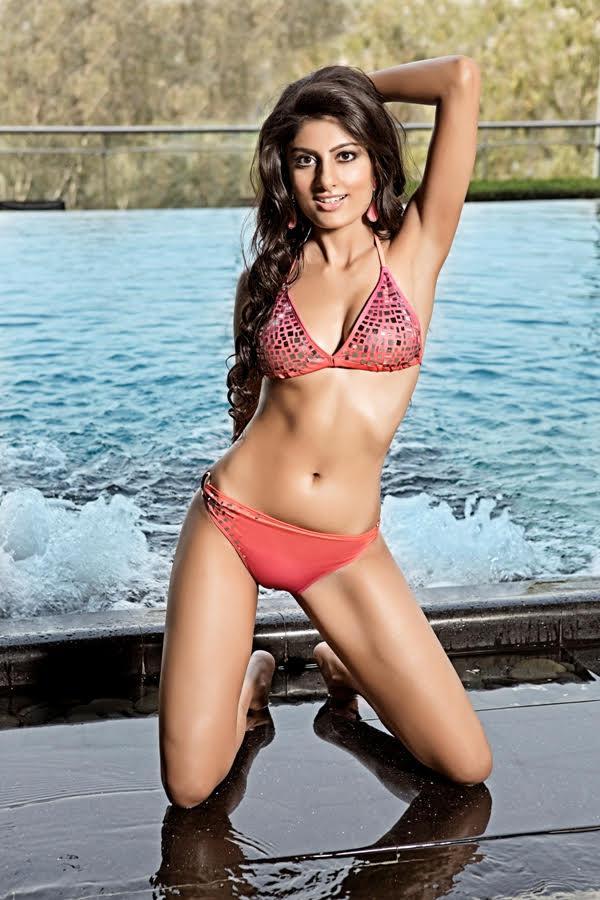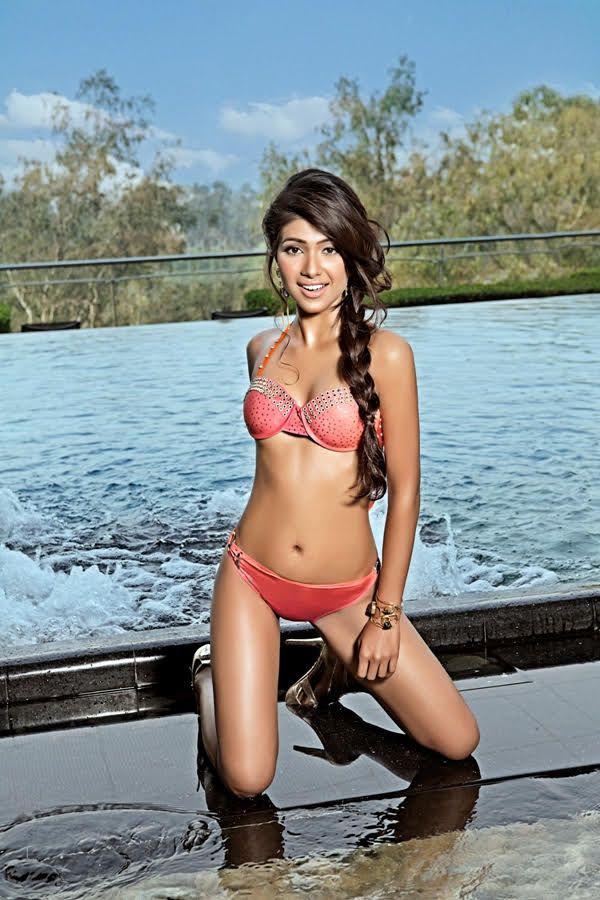The first image is the image on the left, the second image is the image on the right. For the images displayed, is the sentence "An image shows a standing model in a teal bikini with her long black hair swept to the right side and her gaze aimed rightward." factually correct? Answer yes or no. No. The first image is the image on the left, the second image is the image on the right. Examine the images to the left and right. Is the description "A woman is touching her hair." accurate? Answer yes or no. Yes. 